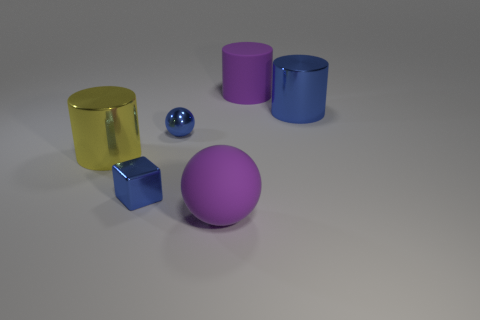Add 4 tiny red matte cylinders. How many objects exist? 10 Subtract all cubes. How many objects are left? 5 Subtract all big blue metallic objects. Subtract all small yellow objects. How many objects are left? 5 Add 4 big yellow cylinders. How many big yellow cylinders are left? 5 Add 4 large blue matte things. How many large blue matte things exist? 4 Subtract 0 green balls. How many objects are left? 6 